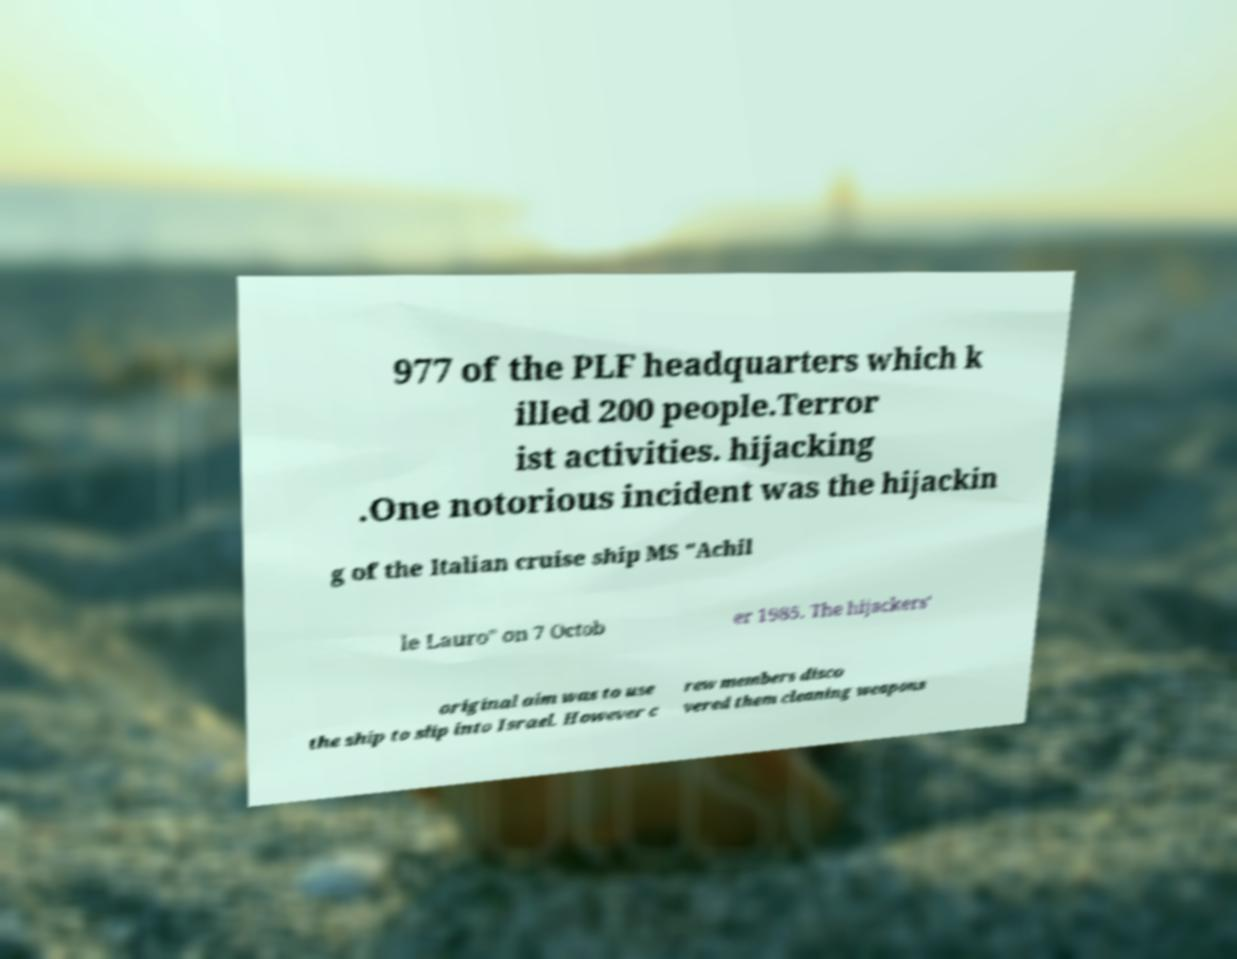There's text embedded in this image that I need extracted. Can you transcribe it verbatim? 977 of the PLF headquarters which k illed 200 people.Terror ist activities. hijacking .One notorious incident was the hijackin g of the Italian cruise ship MS "Achil le Lauro" on 7 Octob er 1985. The hijackers' original aim was to use the ship to slip into Israel. However c rew members disco vered them cleaning weapons 